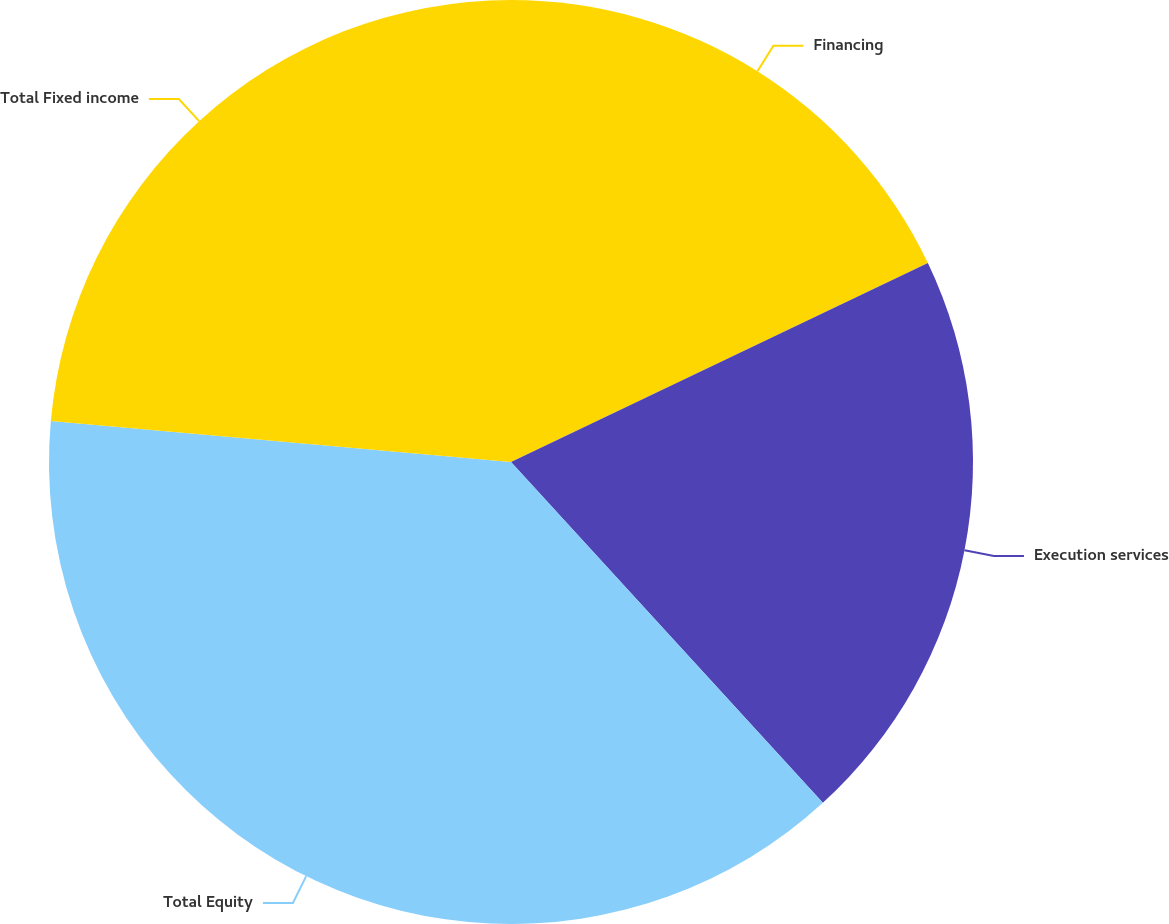Convert chart. <chart><loc_0><loc_0><loc_500><loc_500><pie_chart><fcel>Financing<fcel>Execution services<fcel>Total Equity<fcel>Total Fixed income<nl><fcel>17.91%<fcel>20.3%<fcel>38.21%<fcel>23.59%<nl></chart> 